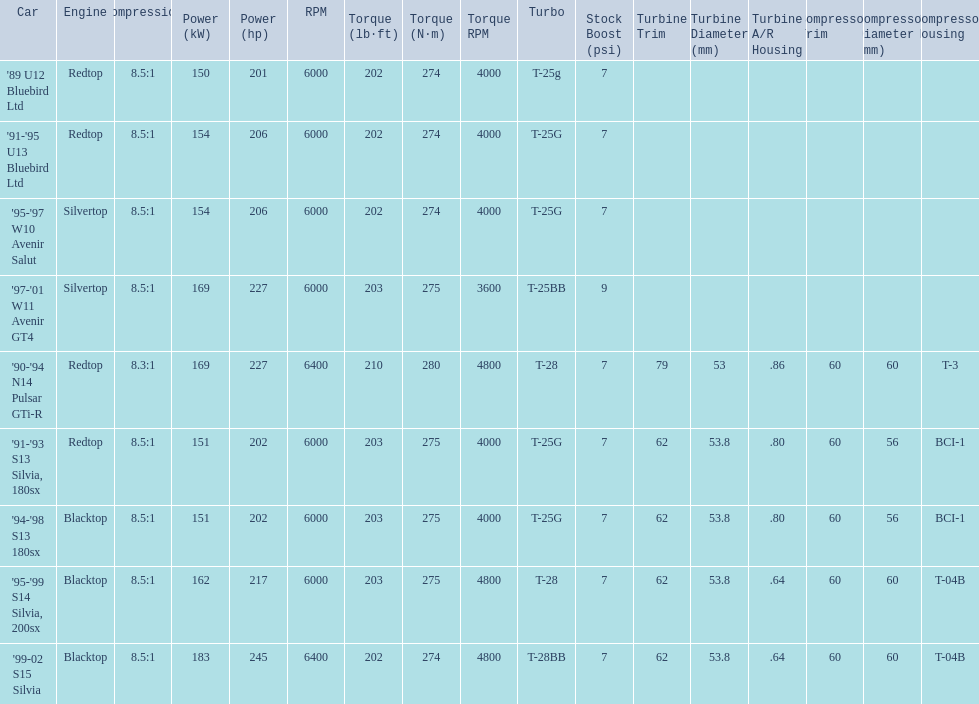What are the listed hp of the cars? 150 kW (201 hp) @ 6000 rpm, 154 kW (206 hp) @ 6000 rpm, 154 kW (206 hp) @ 6000 rpm, 169 kW (227 hp) @ 6000 rpm, 169 kW (227 hp) @ 6400 rpm (Euro: 164 kW (220 hp) @ 6400 rpm), 151 kW (202 hp) @ 6000 rpm, 151 kW (202 hp) @ 6000 rpm, 162 kW (217 hp) @ 6000 rpm, 183 kW (245 hp) @ 6400 rpm. Which is the only car with over 230 hp? '99-02 S15 Silvia. 